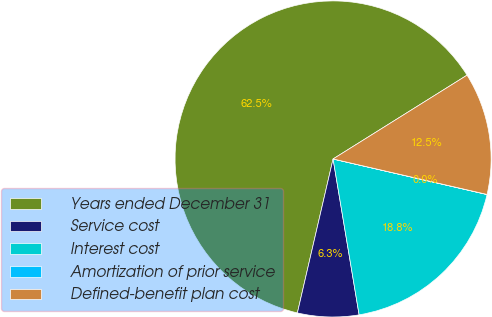<chart> <loc_0><loc_0><loc_500><loc_500><pie_chart><fcel>Years ended December 31<fcel>Service cost<fcel>Interest cost<fcel>Amortization of prior service<fcel>Defined-benefit plan cost<nl><fcel>62.47%<fcel>6.26%<fcel>18.75%<fcel>0.01%<fcel>12.5%<nl></chart> 